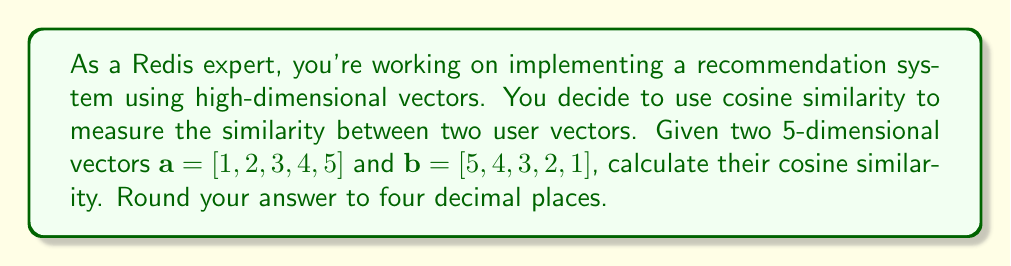What is the answer to this math problem? To calculate the cosine similarity between two vectors $\mathbf{a}$ and $\mathbf{b}$, we use the formula:

$$\text{cosine similarity} = \frac{\mathbf{a} \cdot \mathbf{b}}{\|\mathbf{a}\| \|\mathbf{b}\|}$$

Where $\mathbf{a} \cdot \mathbf{b}$ is the dot product of the vectors, and $\|\mathbf{a}\|$ and $\|\mathbf{b}\|$ are the magnitudes (Euclidean norms) of the vectors.

Step 1: Calculate the dot product $\mathbf{a} \cdot \mathbf{b}$
$$\mathbf{a} \cdot \mathbf{b} = (1 \times 5) + (2 \times 4) + (3 \times 3) + (4 \times 2) + (5 \times 1) = 5 + 8 + 9 + 8 + 5 = 35$$

Step 2: Calculate $\|\mathbf{a}\|$
$$\|\mathbf{a}\| = \sqrt{1^2 + 2^2 + 3^2 + 4^2 + 5^2} = \sqrt{55}$$

Step 3: Calculate $\|\mathbf{b}\|$
$$\|\mathbf{b}\| = \sqrt{5^2 + 4^2 + 3^2 + 2^2 + 1^2} = \sqrt{55}$$

Step 4: Apply the cosine similarity formula
$$\text{cosine similarity} = \frac{35}{\sqrt{55} \times \sqrt{55}} = \frac{35}{55} \approx 0.6364$$

Step 5: Round to four decimal places
$$0.6364$$
Answer: 0.6364 